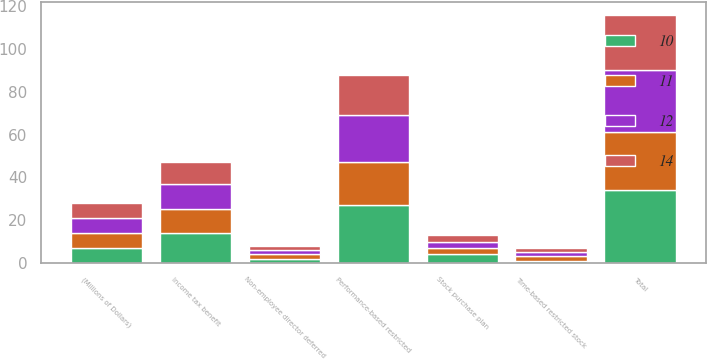Convert chart to OTSL. <chart><loc_0><loc_0><loc_500><loc_500><stacked_bar_chart><ecel><fcel>(Millions of Dollars)<fcel>Performance-based restricted<fcel>Time-based restricted stock<fcel>Non-employee director deferred<fcel>Stock purchase plan<fcel>Total<fcel>Income tax benefit<nl><fcel>10<fcel>7<fcel>27<fcel>1<fcel>2<fcel>4<fcel>34<fcel>14<nl><fcel>12<fcel>7<fcel>22<fcel>2<fcel>2<fcel>3<fcel>29<fcel>12<nl><fcel>11<fcel>7<fcel>20<fcel>2<fcel>2<fcel>3<fcel>27<fcel>11<nl><fcel>14<fcel>7<fcel>19<fcel>2<fcel>2<fcel>3<fcel>26<fcel>10<nl></chart> 